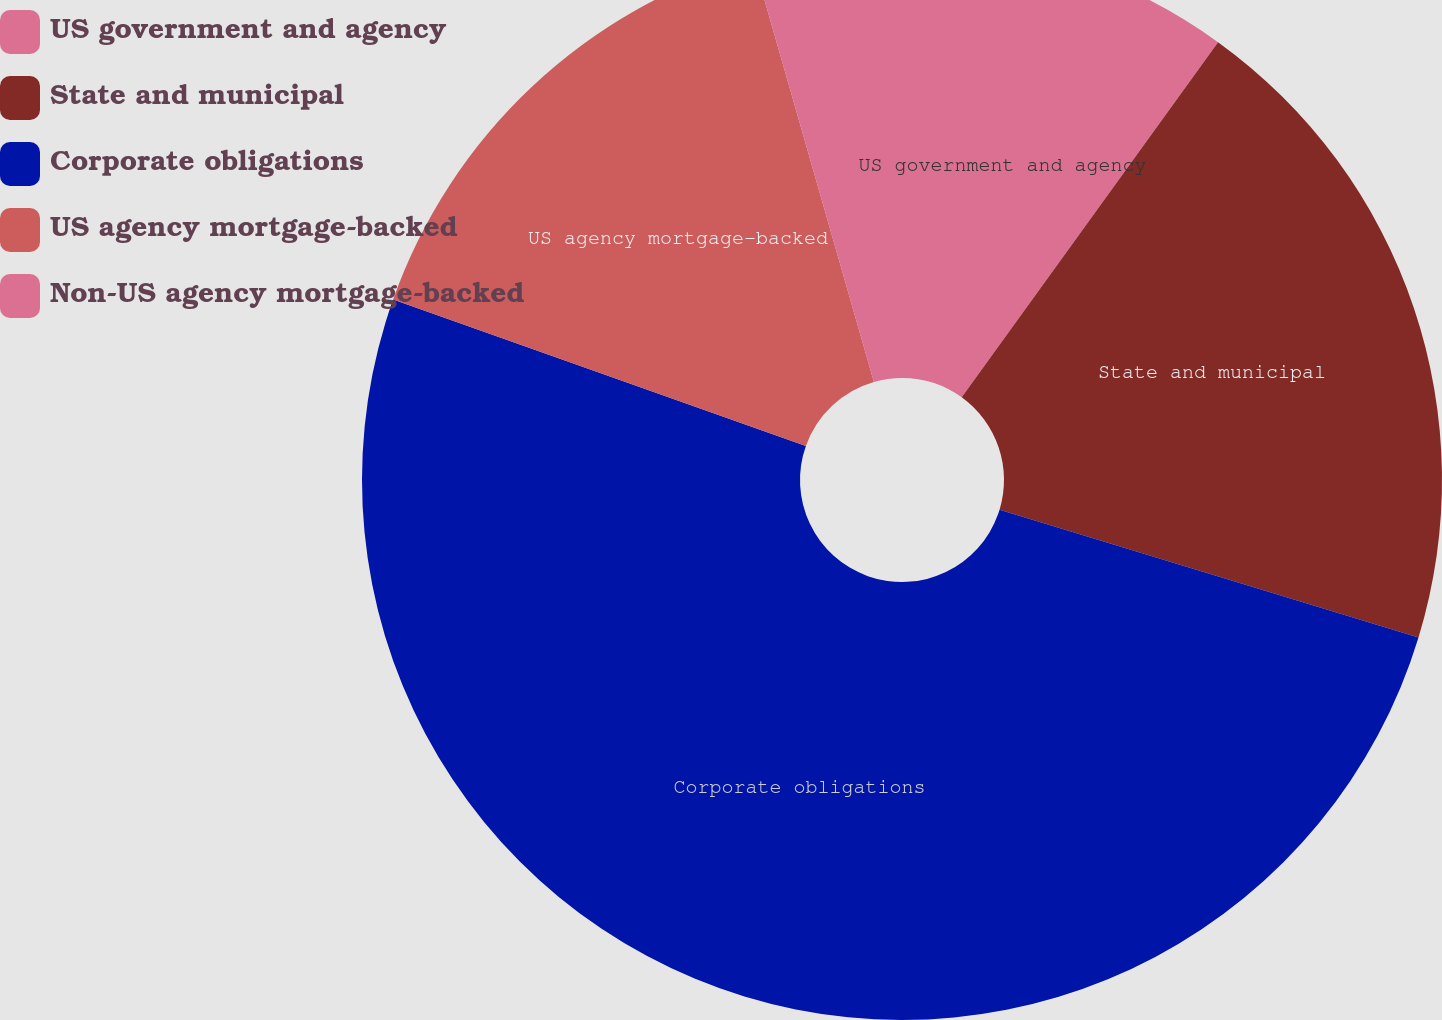<chart> <loc_0><loc_0><loc_500><loc_500><pie_chart><fcel>US government and agency<fcel>State and municipal<fcel>Corporate obligations<fcel>US agency mortgage-backed<fcel>Non-US agency mortgage-backed<nl><fcel>9.95%<fcel>19.76%<fcel>50.71%<fcel>15.13%<fcel>4.44%<nl></chart> 